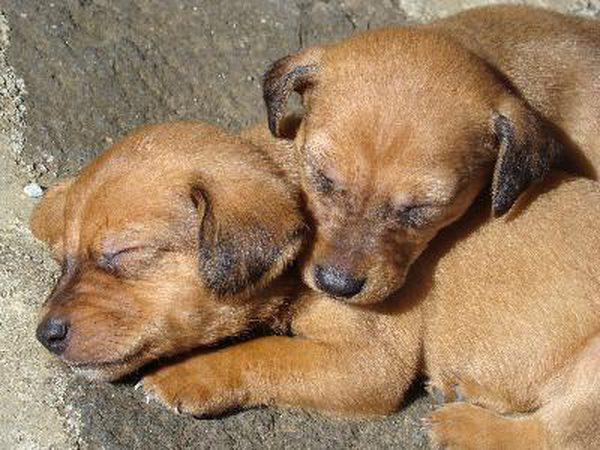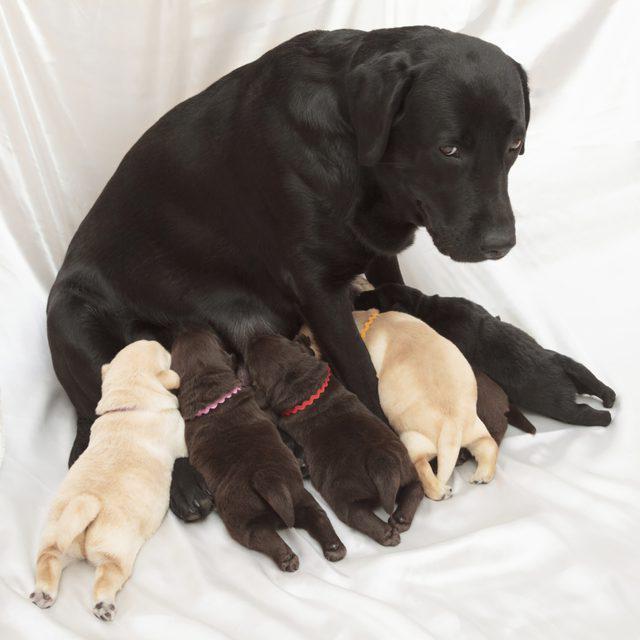The first image is the image on the left, the second image is the image on the right. Given the left and right images, does the statement "There is an adult pug in each image." hold true? Answer yes or no. No. The first image is the image on the left, the second image is the image on the right. Given the left and right images, does the statement "There are exactly two dogs in one of the images." hold true? Answer yes or no. Yes. 